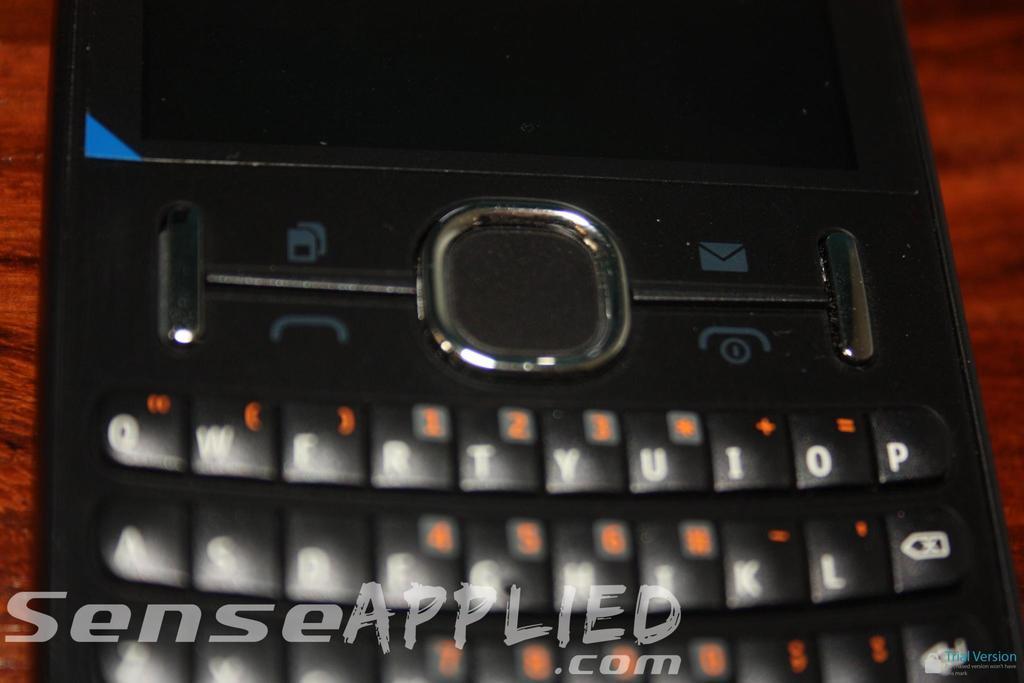Please provide a concise description of this image. In this image I can see a mobile placed on a wooden surface. On the key buttons, I can see the letters and numbers. At the bottom of this image there is some edited text. 